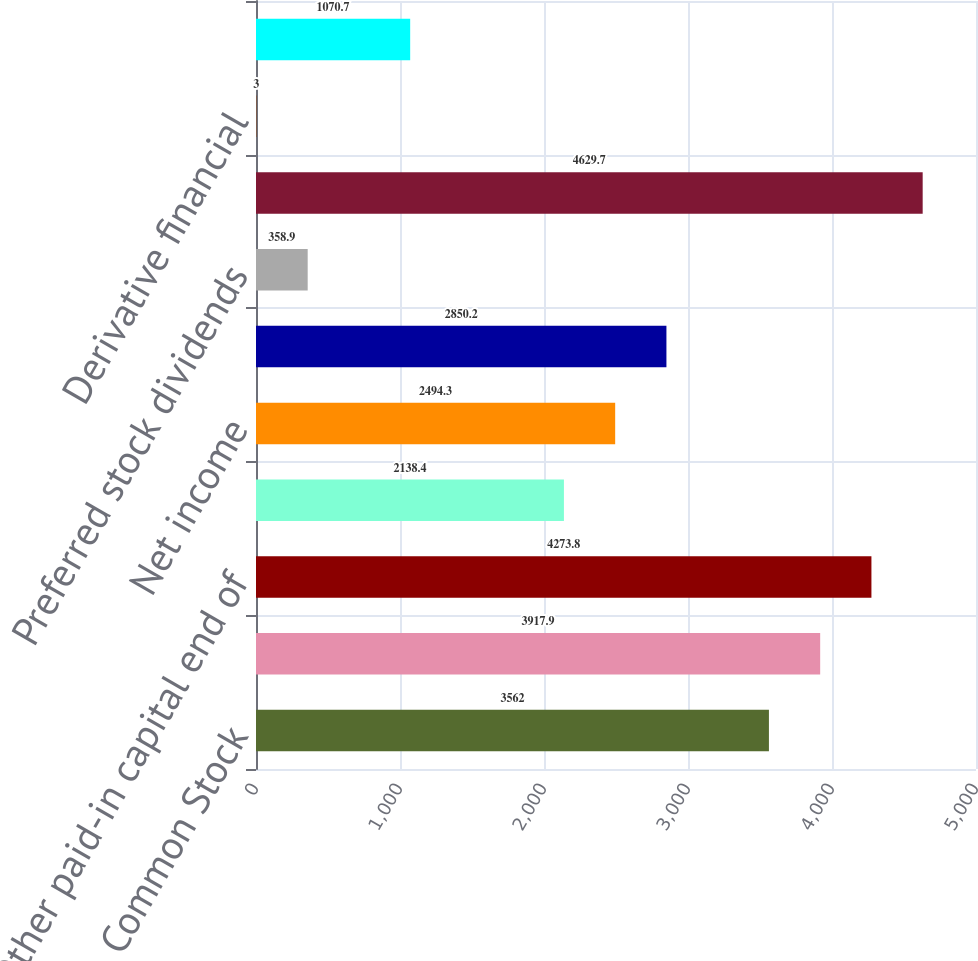<chart> <loc_0><loc_0><loc_500><loc_500><bar_chart><fcel>Common Stock<fcel>Beginning of year<fcel>Other paid-in capital end of<fcel>Preferred Stock Not Subject to<fcel>Net income<fcel>Common stock dividends<fcel>Preferred stock dividends<fcel>Retained earnings end of year<fcel>Derivative financial<fcel>Change in derivative financial<nl><fcel>3562<fcel>3917.9<fcel>4273.8<fcel>2138.4<fcel>2494.3<fcel>2850.2<fcel>358.9<fcel>4629.7<fcel>3<fcel>1070.7<nl></chart> 